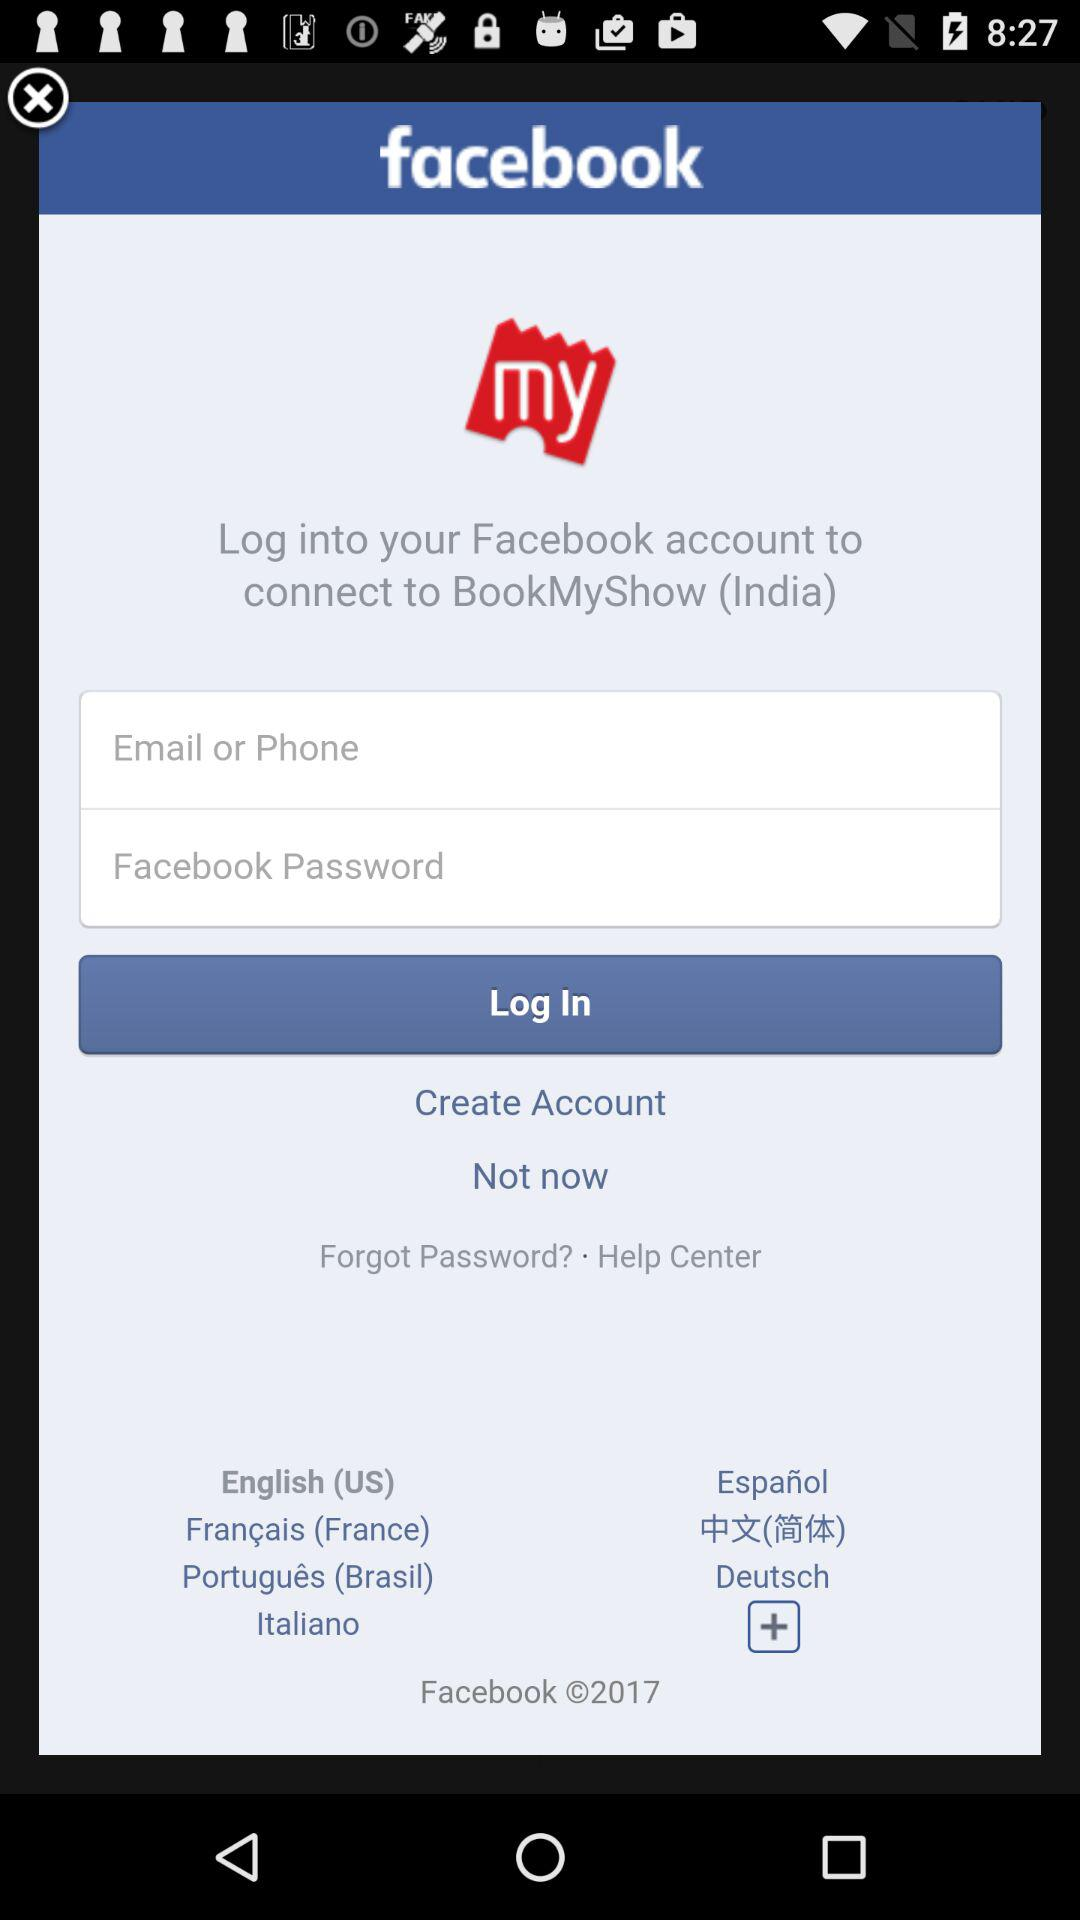Through what application can we log in? You can log in through "facebook". 